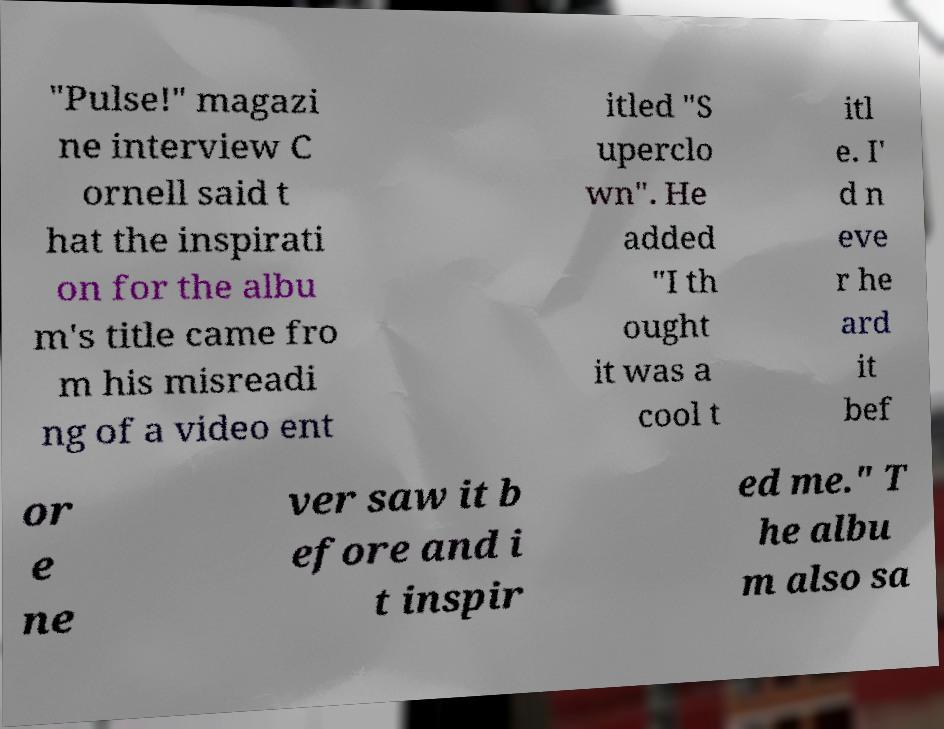Could you assist in decoding the text presented in this image and type it out clearly? "Pulse!" magazi ne interview C ornell said t hat the inspirati on for the albu m's title came fro m his misreadi ng of a video ent itled "S uperclo wn". He added "I th ought it was a cool t itl e. I' d n eve r he ard it bef or e ne ver saw it b efore and i t inspir ed me." T he albu m also sa 